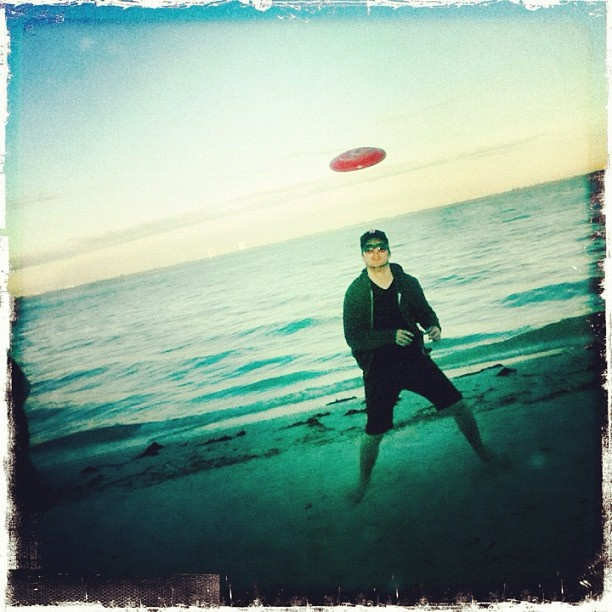Describe the objects in this image and their specific colors. I can see people in lightgray, black, darkgreen, teal, and khaki tones and frisbee in lightgray, salmon, darkgray, lightpink, and brown tones in this image. 